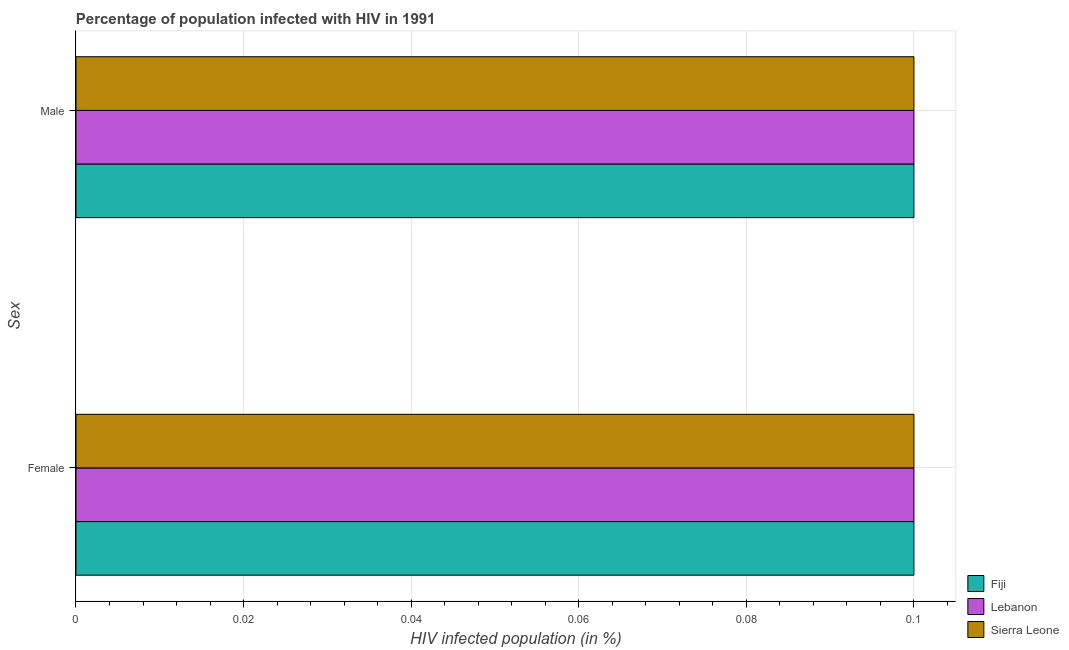How many different coloured bars are there?
Make the answer very short. 3. Are the number of bars per tick equal to the number of legend labels?
Ensure brevity in your answer.  Yes. Are the number of bars on each tick of the Y-axis equal?
Provide a short and direct response. Yes. How many bars are there on the 1st tick from the top?
Your answer should be very brief. 3. How many bars are there on the 1st tick from the bottom?
Your answer should be very brief. 3. What is the percentage of males who are infected with hiv in Fiji?
Provide a succinct answer. 0.1. In which country was the percentage of males who are infected with hiv maximum?
Offer a terse response. Fiji. In which country was the percentage of males who are infected with hiv minimum?
Make the answer very short. Fiji. What is the total percentage of males who are infected with hiv in the graph?
Provide a short and direct response. 0.3. What is the difference between the percentage of males who are infected with hiv in Lebanon and that in Fiji?
Give a very brief answer. 0. What is the difference between the percentage of females who are infected with hiv in Lebanon and the percentage of males who are infected with hiv in Fiji?
Your response must be concise. 0. What is the average percentage of males who are infected with hiv per country?
Offer a terse response. 0.1. What is the difference between the percentage of females who are infected with hiv and percentage of males who are infected with hiv in Lebanon?
Your response must be concise. 0. What is the ratio of the percentage of females who are infected with hiv in Lebanon to that in Fiji?
Keep it short and to the point. 1. Is the percentage of males who are infected with hiv in Fiji less than that in Sierra Leone?
Provide a succinct answer. No. In how many countries, is the percentage of females who are infected with hiv greater than the average percentage of females who are infected with hiv taken over all countries?
Your answer should be very brief. 0. What does the 2nd bar from the top in Male represents?
Offer a terse response. Lebanon. What does the 2nd bar from the bottom in Male represents?
Ensure brevity in your answer.  Lebanon. Are all the bars in the graph horizontal?
Offer a terse response. Yes. How many countries are there in the graph?
Give a very brief answer. 3. What is the difference between two consecutive major ticks on the X-axis?
Provide a short and direct response. 0.02. Are the values on the major ticks of X-axis written in scientific E-notation?
Offer a very short reply. No. Does the graph contain grids?
Your answer should be compact. Yes. Where does the legend appear in the graph?
Offer a terse response. Bottom right. How many legend labels are there?
Give a very brief answer. 3. What is the title of the graph?
Your answer should be very brief. Percentage of population infected with HIV in 1991. Does "East Asia (all income levels)" appear as one of the legend labels in the graph?
Make the answer very short. No. What is the label or title of the X-axis?
Provide a succinct answer. HIV infected population (in %). What is the label or title of the Y-axis?
Keep it short and to the point. Sex. What is the HIV infected population (in %) in Fiji in Female?
Provide a short and direct response. 0.1. What is the HIV infected population (in %) of Lebanon in Female?
Give a very brief answer. 0.1. What is the HIV infected population (in %) in Lebanon in Male?
Give a very brief answer. 0.1. Across all Sex, what is the minimum HIV infected population (in %) of Lebanon?
Your response must be concise. 0.1. Across all Sex, what is the minimum HIV infected population (in %) of Sierra Leone?
Ensure brevity in your answer.  0.1. What is the total HIV infected population (in %) in Fiji in the graph?
Ensure brevity in your answer.  0.2. What is the difference between the HIV infected population (in %) of Fiji in Female and that in Male?
Offer a very short reply. 0. What is the difference between the HIV infected population (in %) of Lebanon in Female and that in Male?
Your answer should be compact. 0. What is the difference between the HIV infected population (in %) of Fiji in Female and the HIV infected population (in %) of Sierra Leone in Male?
Provide a short and direct response. 0. What is the difference between the HIV infected population (in %) in Lebanon in Female and the HIV infected population (in %) in Sierra Leone in Male?
Ensure brevity in your answer.  0. What is the average HIV infected population (in %) of Lebanon per Sex?
Offer a terse response. 0.1. What is the average HIV infected population (in %) of Sierra Leone per Sex?
Give a very brief answer. 0.1. What is the difference between the HIV infected population (in %) of Fiji and HIV infected population (in %) of Lebanon in Female?
Your response must be concise. 0. What is the difference between the HIV infected population (in %) of Fiji and HIV infected population (in %) of Lebanon in Male?
Your answer should be compact. 0. What is the difference between the HIV infected population (in %) in Fiji and HIV infected population (in %) in Sierra Leone in Male?
Ensure brevity in your answer.  0. What is the difference between the HIV infected population (in %) of Lebanon and HIV infected population (in %) of Sierra Leone in Male?
Your answer should be very brief. 0. What is the ratio of the HIV infected population (in %) in Fiji in Female to that in Male?
Give a very brief answer. 1. What is the ratio of the HIV infected population (in %) of Sierra Leone in Female to that in Male?
Your answer should be very brief. 1. What is the difference between the highest and the second highest HIV infected population (in %) of Lebanon?
Ensure brevity in your answer.  0. 